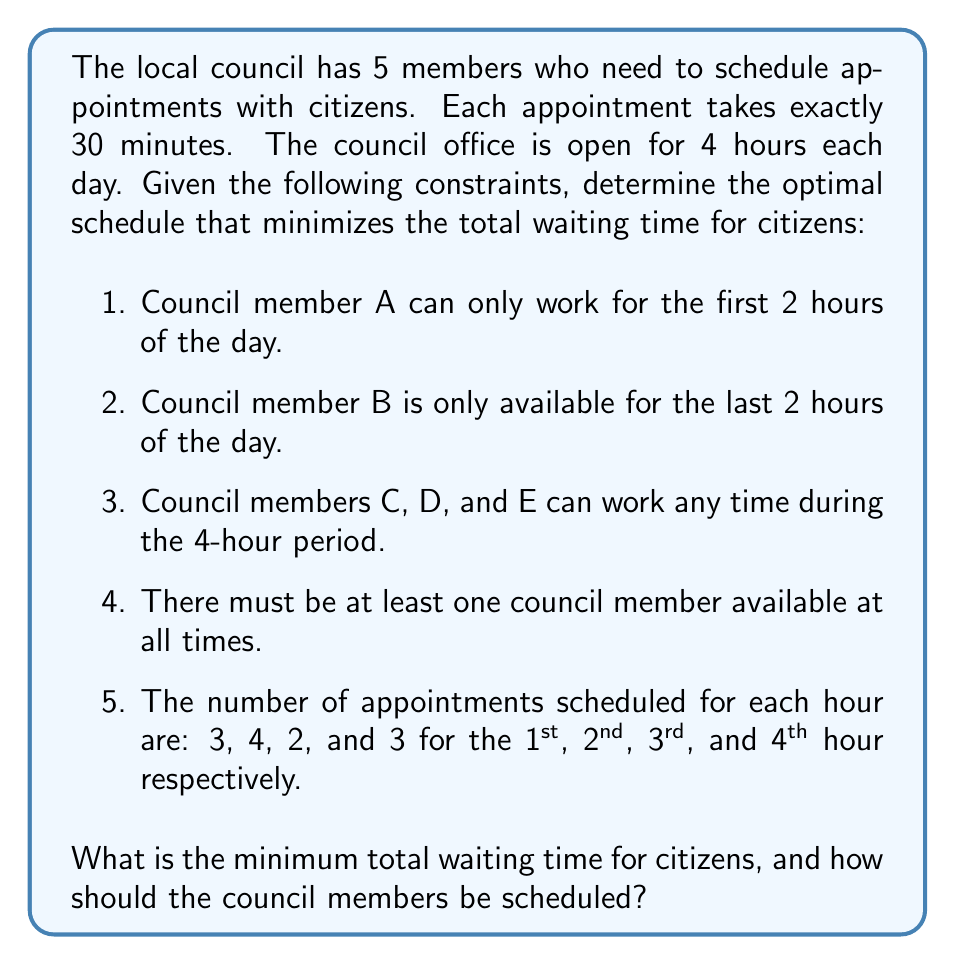Can you answer this question? To solve this optimization problem, we'll use a step-by-step approach:

1) First, let's calculate the total number of appointments:
   $3 + 4 + 2 + 3 = 12$ appointments in total

2) Each council member can handle 2 appointments per hour (since each appointment takes 30 minutes). Let's determine the minimum number of council members needed each hour:

   Hour 1: $\lceil 3/2 \rceil = 2$ members
   Hour 2: $\lceil 4/2 \rceil = 2$ members
   Hour 3: $\lceil 2/2 \rceil = 1$ member
   Hour 4: $\lceil 3/2 \rceil = 2$ members

3) Now, let's assign council members based on the constraints:

   Hour 1 & 2: A must work (constraint 1)
   Hour 3 & 4: B must work (constraint 2)
   
   We need one more member for hours 1, 2, and 4. We can assign C to work all 4 hours to satisfy constraint 4.

4) This assignment satisfies all constraints and provides the exact number of council members needed each hour. Therefore, this is the optimal schedule that minimizes waiting time.

5) To calculate the waiting time:

   Hour 1: 0 waiting time (2 members for 3 appointments)
   Hour 2: 0 waiting time (2 members for 4 appointments)
   Hour 3: 0 waiting time (2 members for 2 appointments)
   Hour 4: 0 waiting time (2 members for 3 appointments)

The total waiting time is 0 minutes, which is the minimum possible.
Answer: The minimum total waiting time for citizens is 0 minutes. The optimal schedule is:

Hour 1 & 2: Council members A and C
Hour 3 & 4: Council members B and C

Council member C works all 4 hours, while members D and E are not needed. 